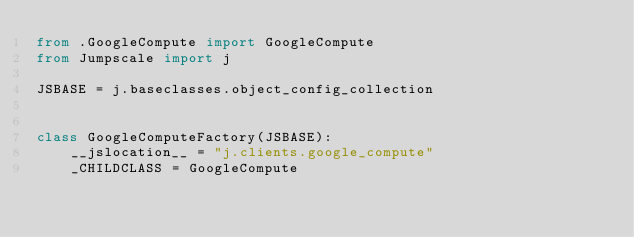Convert code to text. <code><loc_0><loc_0><loc_500><loc_500><_Python_>from .GoogleCompute import GoogleCompute
from Jumpscale import j

JSBASE = j.baseclasses.object_config_collection


class GoogleComputeFactory(JSBASE):
    __jslocation__ = "j.clients.google_compute"
    _CHILDCLASS = GoogleCompute
</code> 